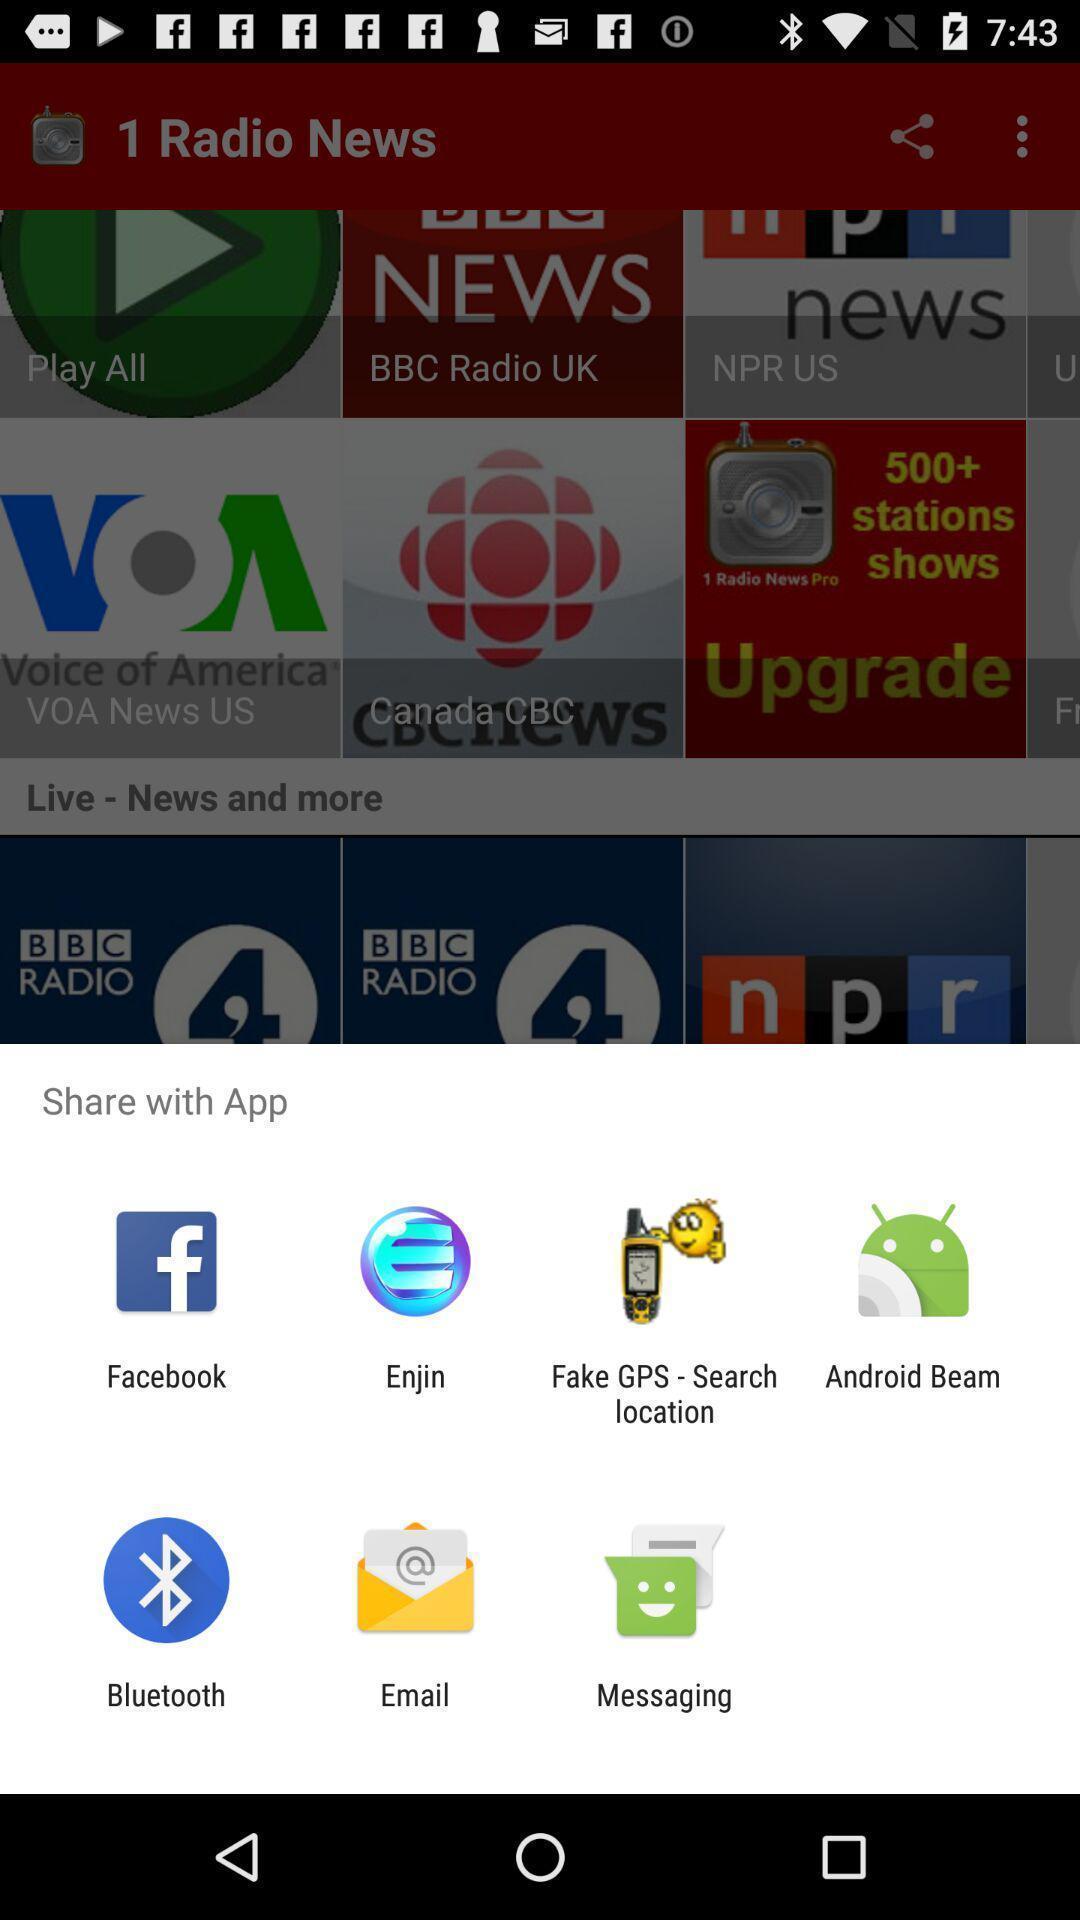Give me a summary of this screen capture. Pop up message for sharing through different apps. 